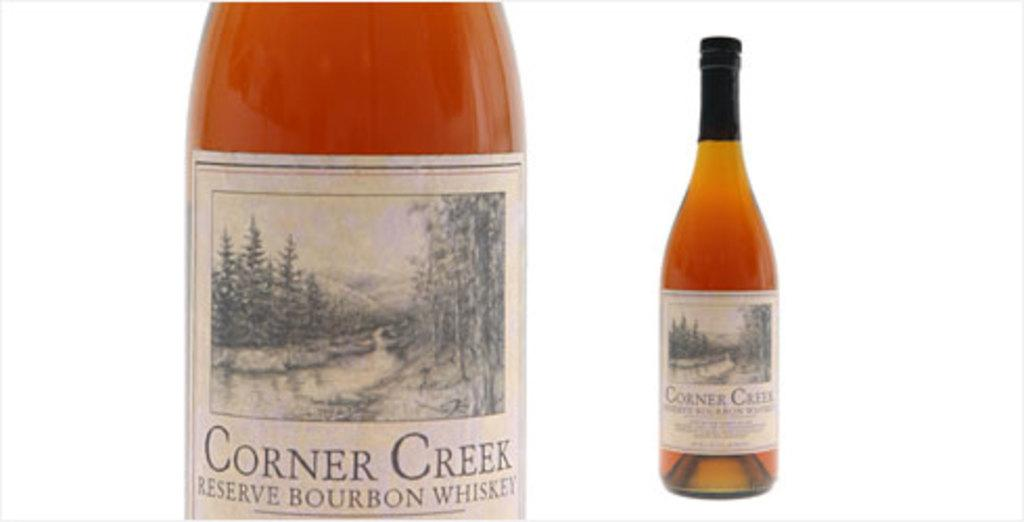What is the main object in the image? There is a whiskey bottle in the image. Is there anything distinctive about the whiskey bottle? Yes, there is a white color sticker around the bottle. How does the daughter interact with the kitten in the dirt in the image? There is no daughter, kitten, or dirt present in the image; it only features a whiskey bottle with a white color sticker. 